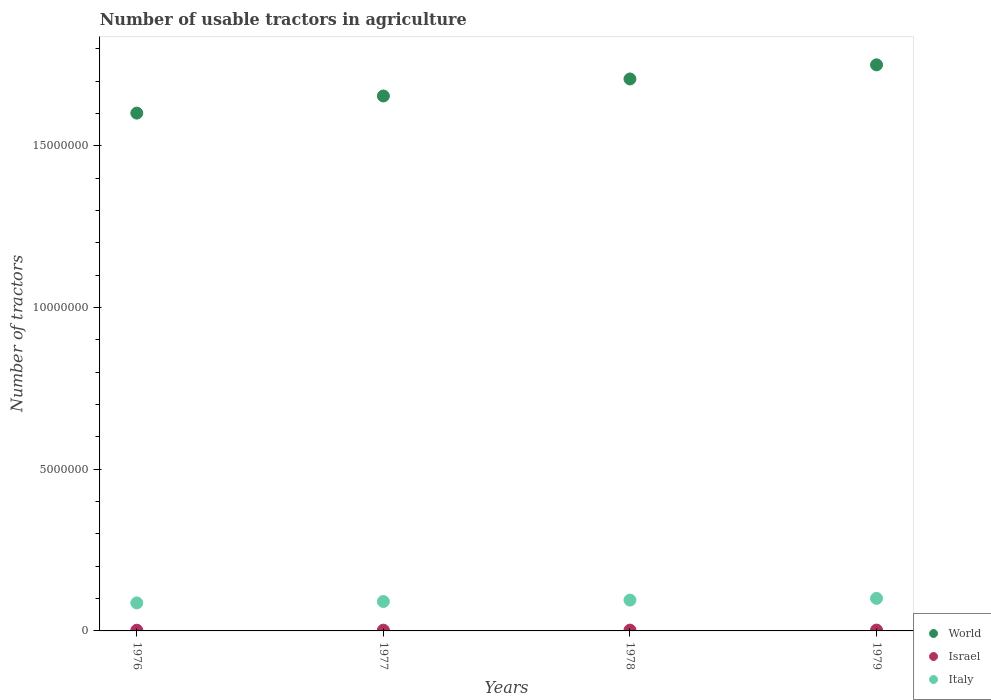How many different coloured dotlines are there?
Provide a short and direct response. 3. Is the number of dotlines equal to the number of legend labels?
Your answer should be very brief. Yes. What is the number of usable tractors in agriculture in World in 1978?
Provide a short and direct response. 1.71e+07. Across all years, what is the maximum number of usable tractors in agriculture in Israel?
Your response must be concise. 2.56e+04. Across all years, what is the minimum number of usable tractors in agriculture in World?
Keep it short and to the point. 1.60e+07. In which year was the number of usable tractors in agriculture in Israel maximum?
Your response must be concise. 1979. In which year was the number of usable tractors in agriculture in World minimum?
Offer a very short reply. 1976. What is the total number of usable tractors in agriculture in Italy in the graph?
Offer a terse response. 3.73e+06. What is the difference between the number of usable tractors in agriculture in Israel in 1977 and that in 1978?
Your response must be concise. -1450. What is the difference between the number of usable tractors in agriculture in Israel in 1979 and the number of usable tractors in agriculture in World in 1978?
Ensure brevity in your answer.  -1.70e+07. What is the average number of usable tractors in agriculture in Israel per year?
Provide a short and direct response. 2.35e+04. In the year 1979, what is the difference between the number of usable tractors in agriculture in World and number of usable tractors in agriculture in Israel?
Give a very brief answer. 1.75e+07. What is the ratio of the number of usable tractors in agriculture in World in 1978 to that in 1979?
Offer a very short reply. 0.98. Is the number of usable tractors in agriculture in World in 1978 less than that in 1979?
Provide a short and direct response. Yes. Is the difference between the number of usable tractors in agriculture in World in 1976 and 1978 greater than the difference between the number of usable tractors in agriculture in Israel in 1976 and 1978?
Ensure brevity in your answer.  No. What is the difference between the highest and the second highest number of usable tractors in agriculture in World?
Your response must be concise. 4.36e+05. What is the difference between the highest and the lowest number of usable tractors in agriculture in World?
Make the answer very short. 1.49e+06. Is the sum of the number of usable tractors in agriculture in Italy in 1978 and 1979 greater than the maximum number of usable tractors in agriculture in World across all years?
Give a very brief answer. No. Does the number of usable tractors in agriculture in Israel monotonically increase over the years?
Make the answer very short. Yes. Is the number of usable tractors in agriculture in World strictly greater than the number of usable tractors in agriculture in Italy over the years?
Make the answer very short. Yes. Is the number of usable tractors in agriculture in World strictly less than the number of usable tractors in agriculture in Italy over the years?
Provide a short and direct response. No. How many dotlines are there?
Give a very brief answer. 3. Are the values on the major ticks of Y-axis written in scientific E-notation?
Offer a very short reply. No. Does the graph contain any zero values?
Offer a terse response. No. Does the graph contain grids?
Ensure brevity in your answer.  No. How many legend labels are there?
Your answer should be compact. 3. What is the title of the graph?
Give a very brief answer. Number of usable tractors in agriculture. Does "Morocco" appear as one of the legend labels in the graph?
Provide a succinct answer. No. What is the label or title of the X-axis?
Your answer should be very brief. Years. What is the label or title of the Y-axis?
Provide a succinct answer. Number of tractors. What is the Number of tractors in World in 1976?
Offer a very short reply. 1.60e+07. What is the Number of tractors of Israel in 1976?
Your answer should be compact. 2.11e+04. What is the Number of tractors in Italy in 1976?
Provide a short and direct response. 8.66e+05. What is the Number of tractors of World in 1977?
Keep it short and to the point. 1.65e+07. What is the Number of tractors of Israel in 1977?
Provide a succinct answer. 2.28e+04. What is the Number of tractors in Italy in 1977?
Make the answer very short. 9.10e+05. What is the Number of tractors in World in 1978?
Your answer should be very brief. 1.71e+07. What is the Number of tractors in Israel in 1978?
Provide a short and direct response. 2.43e+04. What is the Number of tractors in Italy in 1978?
Provide a succinct answer. 9.53e+05. What is the Number of tractors of World in 1979?
Provide a succinct answer. 1.75e+07. What is the Number of tractors in Israel in 1979?
Make the answer very short. 2.56e+04. What is the Number of tractors of Italy in 1979?
Your answer should be very brief. 1.01e+06. Across all years, what is the maximum Number of tractors of World?
Offer a terse response. 1.75e+07. Across all years, what is the maximum Number of tractors of Israel?
Offer a very short reply. 2.56e+04. Across all years, what is the maximum Number of tractors of Italy?
Offer a terse response. 1.01e+06. Across all years, what is the minimum Number of tractors of World?
Keep it short and to the point. 1.60e+07. Across all years, what is the minimum Number of tractors in Israel?
Ensure brevity in your answer.  2.11e+04. Across all years, what is the minimum Number of tractors in Italy?
Make the answer very short. 8.66e+05. What is the total Number of tractors of World in the graph?
Ensure brevity in your answer.  6.71e+07. What is the total Number of tractors in Israel in the graph?
Provide a short and direct response. 9.38e+04. What is the total Number of tractors in Italy in the graph?
Make the answer very short. 3.73e+06. What is the difference between the Number of tractors of World in 1976 and that in 1977?
Ensure brevity in your answer.  -5.29e+05. What is the difference between the Number of tractors in Israel in 1976 and that in 1977?
Your answer should be compact. -1750. What is the difference between the Number of tractors of Italy in 1976 and that in 1977?
Offer a very short reply. -4.39e+04. What is the difference between the Number of tractors of World in 1976 and that in 1978?
Your answer should be very brief. -1.06e+06. What is the difference between the Number of tractors of Israel in 1976 and that in 1978?
Provide a succinct answer. -3200. What is the difference between the Number of tractors of Italy in 1976 and that in 1978?
Provide a succinct answer. -8.75e+04. What is the difference between the Number of tractors in World in 1976 and that in 1979?
Your response must be concise. -1.49e+06. What is the difference between the Number of tractors of Israel in 1976 and that in 1979?
Your response must be concise. -4500. What is the difference between the Number of tractors of Italy in 1976 and that in 1979?
Your answer should be very brief. -1.40e+05. What is the difference between the Number of tractors in World in 1977 and that in 1978?
Keep it short and to the point. -5.26e+05. What is the difference between the Number of tractors in Israel in 1977 and that in 1978?
Provide a short and direct response. -1450. What is the difference between the Number of tractors in Italy in 1977 and that in 1978?
Your answer should be very brief. -4.36e+04. What is the difference between the Number of tractors of World in 1977 and that in 1979?
Offer a terse response. -9.63e+05. What is the difference between the Number of tractors of Israel in 1977 and that in 1979?
Make the answer very short. -2750. What is the difference between the Number of tractors in Italy in 1977 and that in 1979?
Offer a terse response. -9.65e+04. What is the difference between the Number of tractors of World in 1978 and that in 1979?
Offer a very short reply. -4.36e+05. What is the difference between the Number of tractors in Israel in 1978 and that in 1979?
Make the answer very short. -1300. What is the difference between the Number of tractors in Italy in 1978 and that in 1979?
Offer a very short reply. -5.29e+04. What is the difference between the Number of tractors in World in 1976 and the Number of tractors in Israel in 1977?
Offer a very short reply. 1.60e+07. What is the difference between the Number of tractors of World in 1976 and the Number of tractors of Italy in 1977?
Keep it short and to the point. 1.51e+07. What is the difference between the Number of tractors of Israel in 1976 and the Number of tractors of Italy in 1977?
Keep it short and to the point. -8.88e+05. What is the difference between the Number of tractors in World in 1976 and the Number of tractors in Israel in 1978?
Your answer should be compact. 1.60e+07. What is the difference between the Number of tractors of World in 1976 and the Number of tractors of Italy in 1978?
Make the answer very short. 1.51e+07. What is the difference between the Number of tractors in Israel in 1976 and the Number of tractors in Italy in 1978?
Provide a succinct answer. -9.32e+05. What is the difference between the Number of tractors of World in 1976 and the Number of tractors of Israel in 1979?
Provide a succinct answer. 1.60e+07. What is the difference between the Number of tractors in World in 1976 and the Number of tractors in Italy in 1979?
Provide a short and direct response. 1.50e+07. What is the difference between the Number of tractors in Israel in 1976 and the Number of tractors in Italy in 1979?
Give a very brief answer. -9.85e+05. What is the difference between the Number of tractors of World in 1977 and the Number of tractors of Israel in 1978?
Keep it short and to the point. 1.65e+07. What is the difference between the Number of tractors in World in 1977 and the Number of tractors in Italy in 1978?
Ensure brevity in your answer.  1.56e+07. What is the difference between the Number of tractors of Israel in 1977 and the Number of tractors of Italy in 1978?
Your answer should be compact. -9.30e+05. What is the difference between the Number of tractors of World in 1977 and the Number of tractors of Israel in 1979?
Offer a terse response. 1.65e+07. What is the difference between the Number of tractors in World in 1977 and the Number of tractors in Italy in 1979?
Provide a short and direct response. 1.55e+07. What is the difference between the Number of tractors of Israel in 1977 and the Number of tractors of Italy in 1979?
Provide a succinct answer. -9.83e+05. What is the difference between the Number of tractors of World in 1978 and the Number of tractors of Israel in 1979?
Your answer should be compact. 1.70e+07. What is the difference between the Number of tractors of World in 1978 and the Number of tractors of Italy in 1979?
Offer a very short reply. 1.61e+07. What is the difference between the Number of tractors in Israel in 1978 and the Number of tractors in Italy in 1979?
Provide a succinct answer. -9.82e+05. What is the average Number of tractors of World per year?
Offer a terse response. 1.68e+07. What is the average Number of tractors of Israel per year?
Provide a short and direct response. 2.35e+04. What is the average Number of tractors in Italy per year?
Your answer should be compact. 9.34e+05. In the year 1976, what is the difference between the Number of tractors in World and Number of tractors in Israel?
Ensure brevity in your answer.  1.60e+07. In the year 1976, what is the difference between the Number of tractors of World and Number of tractors of Italy?
Your response must be concise. 1.51e+07. In the year 1976, what is the difference between the Number of tractors in Israel and Number of tractors in Italy?
Give a very brief answer. -8.45e+05. In the year 1977, what is the difference between the Number of tractors in World and Number of tractors in Israel?
Ensure brevity in your answer.  1.65e+07. In the year 1977, what is the difference between the Number of tractors in World and Number of tractors in Italy?
Give a very brief answer. 1.56e+07. In the year 1977, what is the difference between the Number of tractors of Israel and Number of tractors of Italy?
Offer a very short reply. -8.87e+05. In the year 1978, what is the difference between the Number of tractors of World and Number of tractors of Israel?
Ensure brevity in your answer.  1.70e+07. In the year 1978, what is the difference between the Number of tractors of World and Number of tractors of Italy?
Offer a terse response. 1.61e+07. In the year 1978, what is the difference between the Number of tractors of Israel and Number of tractors of Italy?
Make the answer very short. -9.29e+05. In the year 1979, what is the difference between the Number of tractors of World and Number of tractors of Israel?
Make the answer very short. 1.75e+07. In the year 1979, what is the difference between the Number of tractors of World and Number of tractors of Italy?
Keep it short and to the point. 1.65e+07. In the year 1979, what is the difference between the Number of tractors of Israel and Number of tractors of Italy?
Offer a very short reply. -9.80e+05. What is the ratio of the Number of tractors of World in 1976 to that in 1977?
Keep it short and to the point. 0.97. What is the ratio of the Number of tractors in Israel in 1976 to that in 1977?
Your answer should be compact. 0.92. What is the ratio of the Number of tractors in Italy in 1976 to that in 1977?
Your response must be concise. 0.95. What is the ratio of the Number of tractors in World in 1976 to that in 1978?
Make the answer very short. 0.94. What is the ratio of the Number of tractors in Israel in 1976 to that in 1978?
Your answer should be compact. 0.87. What is the ratio of the Number of tractors in Italy in 1976 to that in 1978?
Keep it short and to the point. 0.91. What is the ratio of the Number of tractors in World in 1976 to that in 1979?
Keep it short and to the point. 0.91. What is the ratio of the Number of tractors of Israel in 1976 to that in 1979?
Provide a short and direct response. 0.82. What is the ratio of the Number of tractors in Italy in 1976 to that in 1979?
Give a very brief answer. 0.86. What is the ratio of the Number of tractors in World in 1977 to that in 1978?
Make the answer very short. 0.97. What is the ratio of the Number of tractors in Israel in 1977 to that in 1978?
Offer a terse response. 0.94. What is the ratio of the Number of tractors of Italy in 1977 to that in 1978?
Offer a very short reply. 0.95. What is the ratio of the Number of tractors of World in 1977 to that in 1979?
Give a very brief answer. 0.94. What is the ratio of the Number of tractors in Israel in 1977 to that in 1979?
Keep it short and to the point. 0.89. What is the ratio of the Number of tractors of Italy in 1977 to that in 1979?
Ensure brevity in your answer.  0.9. What is the ratio of the Number of tractors in World in 1978 to that in 1979?
Ensure brevity in your answer.  0.98. What is the ratio of the Number of tractors in Israel in 1978 to that in 1979?
Provide a short and direct response. 0.95. What is the ratio of the Number of tractors in Italy in 1978 to that in 1979?
Your answer should be compact. 0.95. What is the difference between the highest and the second highest Number of tractors in World?
Make the answer very short. 4.36e+05. What is the difference between the highest and the second highest Number of tractors of Israel?
Your response must be concise. 1300. What is the difference between the highest and the second highest Number of tractors of Italy?
Your answer should be compact. 5.29e+04. What is the difference between the highest and the lowest Number of tractors of World?
Offer a terse response. 1.49e+06. What is the difference between the highest and the lowest Number of tractors of Israel?
Ensure brevity in your answer.  4500. What is the difference between the highest and the lowest Number of tractors of Italy?
Give a very brief answer. 1.40e+05. 